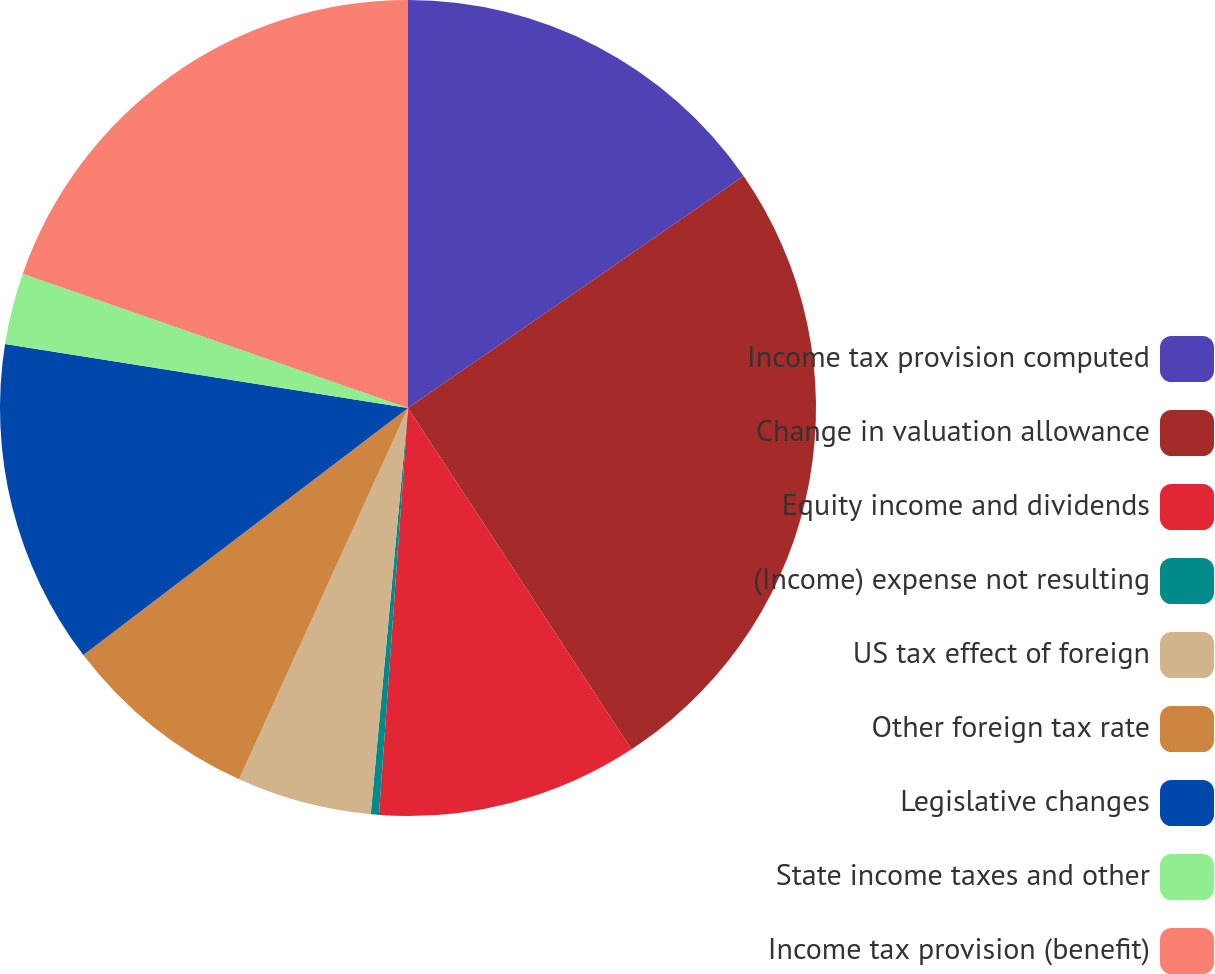Convert chart to OTSL. <chart><loc_0><loc_0><loc_500><loc_500><pie_chart><fcel>Income tax provision computed<fcel>Change in valuation allowance<fcel>Equity income and dividends<fcel>(Income) expense not resulting<fcel>US tax effect of foreign<fcel>Other foreign tax rate<fcel>Legislative changes<fcel>State income taxes and other<fcel>Income tax provision (benefit)<nl><fcel>15.37%<fcel>25.4%<fcel>10.36%<fcel>0.32%<fcel>5.34%<fcel>7.85%<fcel>12.86%<fcel>2.83%<fcel>19.66%<nl></chart> 